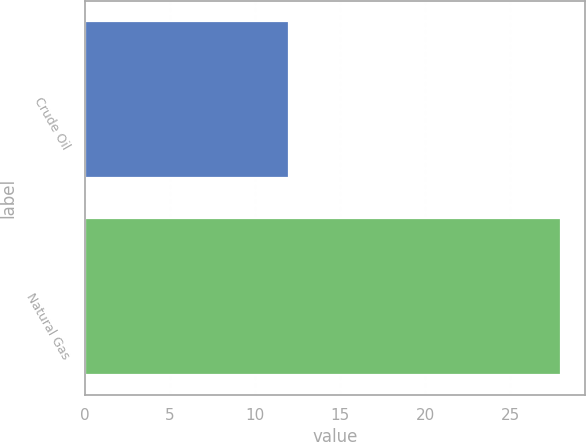<chart> <loc_0><loc_0><loc_500><loc_500><bar_chart><fcel>Crude Oil<fcel>Natural Gas<nl><fcel>12<fcel>28<nl></chart> 